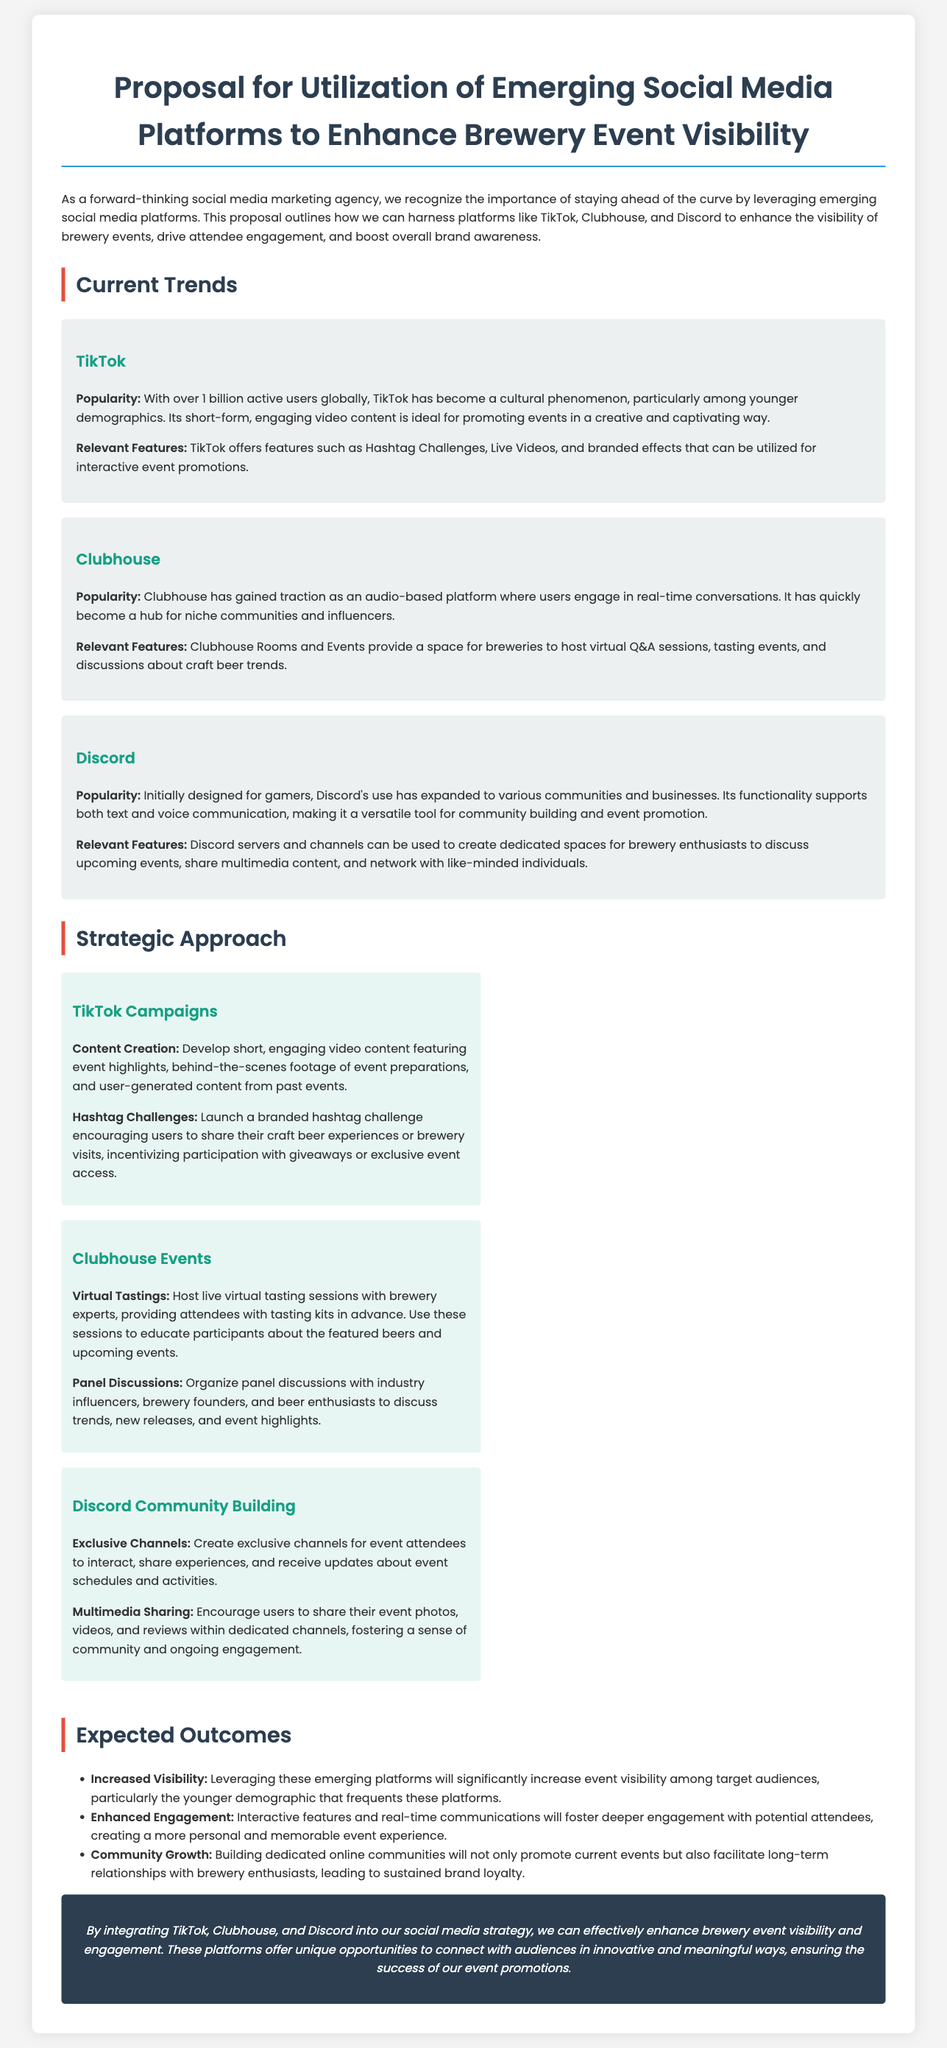What is the primary goal of the proposal? The proposal aims to enhance brewery event visibility by leveraging emerging social media platforms.
Answer: Enhance brewery event visibility How many active users does TikTok have globally? The document states that TikTok has over 1 billion active users globally.
Answer: 1 billion What platform is designated for live virtual tastings? Clubhouse is specified for hosting live virtual tasting sessions in the proposal.
Answer: Clubhouse Which platform allows for exclusive channels for event discussions? The proposal mentions that Discord allows for creating exclusive channels for attendees.
Answer: Discord What type of discussions are suggested for Clubhouse? The proposal suggests organizing panel discussions with industry influencers on Clubhouse.
Answer: Panel discussions What is the expected outcome related to brand loyalty? The proposal states that building dedicated online communities will lead to sustained brand loyalty.
Answer: Sustained brand loyalty What is one interactive feature offered by TikTok for event promotion? Hashtag Challenges are mentioned as an interactive feature on TikTok for promoting events.
Answer: Hashtag Challenges What is the intended demographic for increased visibility? The proposal identifies younger demographics as the target audience for event visibility.
Answer: Younger demographics 